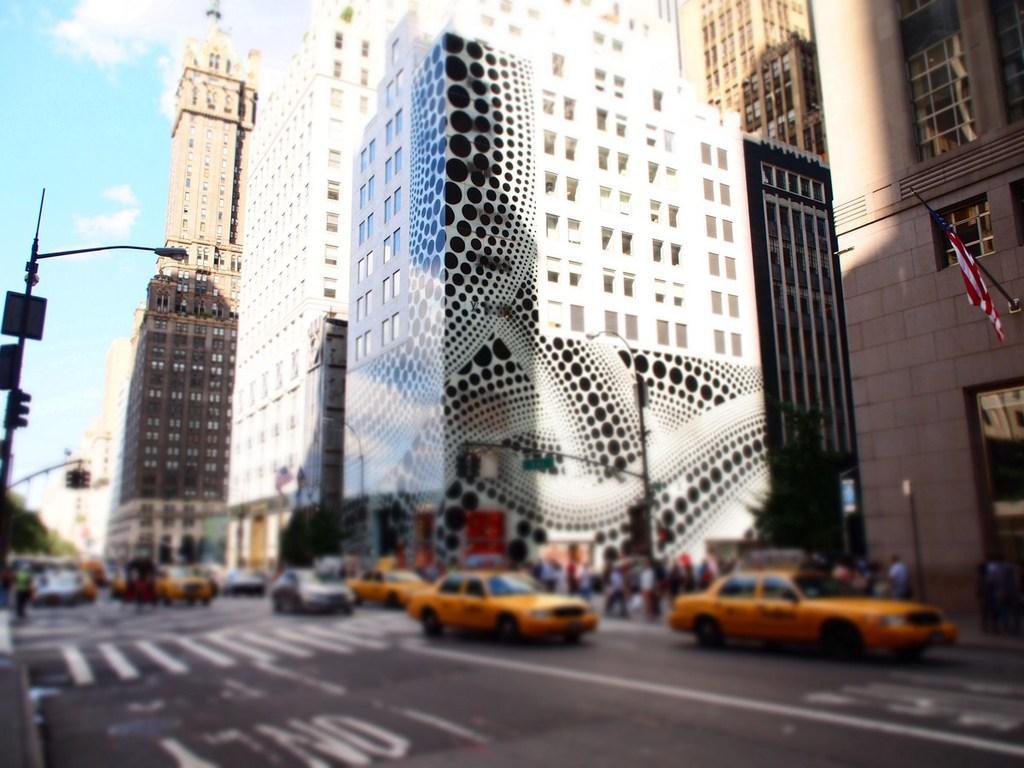In one or two sentences, can you explain what this image depicts? In this image there is a road on that road there are cars, in the background there are buildings. 